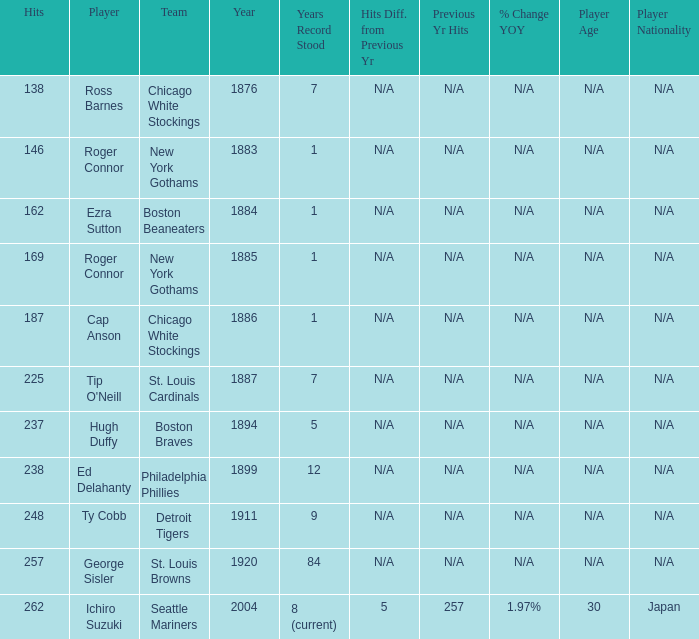Name the hits for years before 1883 138.0. 